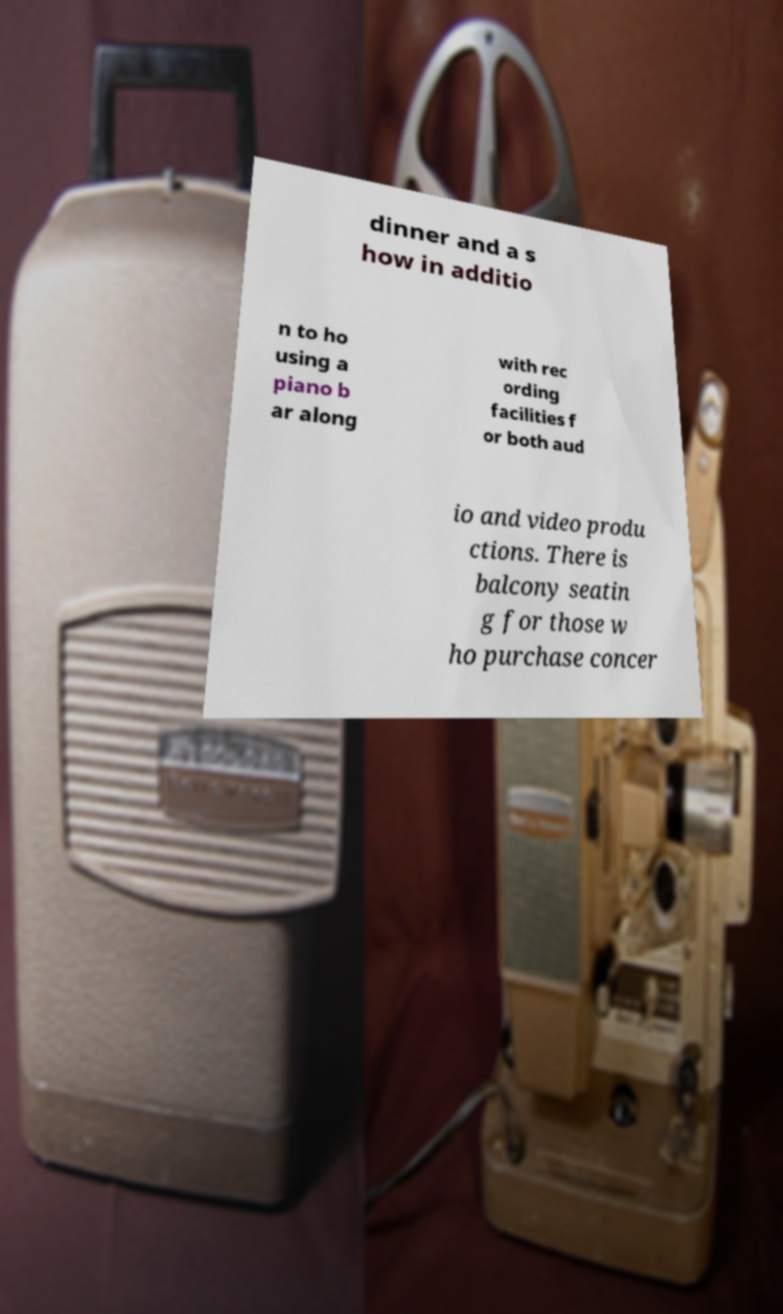What messages or text are displayed in this image? I need them in a readable, typed format. dinner and a s how in additio n to ho using a piano b ar along with rec ording facilities f or both aud io and video produ ctions. There is balcony seatin g for those w ho purchase concer 